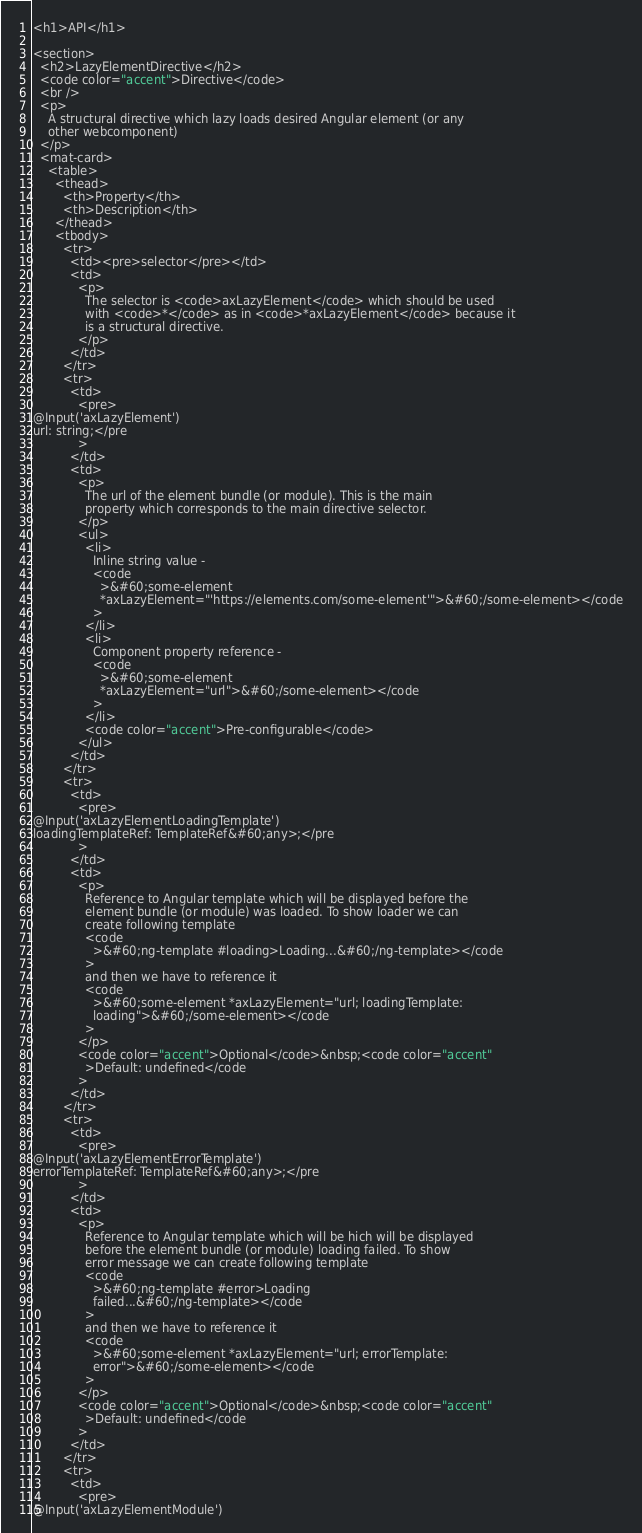<code> <loc_0><loc_0><loc_500><loc_500><_HTML_><h1>API</h1>

<section>
  <h2>LazyElementDirective</h2>
  <code color="accent">Directive</code>
  <br />
  <p>
    A structural directive which lazy loads desired Angular element (or any
    other webcomponent)
  </p>
  <mat-card>
    <table>
      <thead>
        <th>Property</th>
        <th>Description</th>
      </thead>
      <tbody>
        <tr>
          <td><pre>selector</pre></td>
          <td>
            <p>
              The selector is <code>axLazyElement</code> which should be used
              with <code>*</code> as in <code>*axLazyElement</code> because it
              is a structural directive.
            </p>
          </td>
        </tr>
        <tr>
          <td>
            <pre>
@Input('axLazyElement')
url: string;</pre
            >
          </td>
          <td>
            <p>
              The url of the element bundle (or module). This is the main
              property which corresponds to the main directive selector.
            </p>
            <ul>
              <li>
                Inline string value -
                <code
                  >&#60;some-element
                  *axLazyElement="'https://elements.com/some-element'">&#60;/some-element></code
                >
              </li>
              <li>
                Component property reference -
                <code
                  >&#60;some-element
                  *axLazyElement="url">&#60;/some-element></code
                >
              </li>
              <code color="accent">Pre-configurable</code>
            </ul>
          </td>
        </tr>
        <tr>
          <td>
            <pre>
@Input('axLazyElementLoadingTemplate')
loadingTemplateRef: TemplateRef&#60;any>;</pre
            >
          </td>
          <td>
            <p>
              Reference to Angular template which will be displayed before the
              element bundle (or module) was loaded. To show loader we can
              create following template
              <code
                >&#60;ng-template #loading>Loading...&#60;/ng-template></code
              >
              and then we have to reference it
              <code
                >&#60;some-element *axLazyElement="url; loadingTemplate:
                loading">&#60;/some-element></code
              >
            </p>
            <code color="accent">Optional</code>&nbsp;<code color="accent"
              >Default: undefined</code
            >
          </td>
        </tr>
        <tr>
          <td>
            <pre>
@Input('axLazyElementErrorTemplate')
errorTemplateRef: TemplateRef&#60;any>;</pre
            >
          </td>
          <td>
            <p>
              Reference to Angular template which will be hich will be displayed
              before the element bundle (or module) loading failed. To show
              error message we can create following template
              <code
                >&#60;ng-template #error>Loading
                failed...&#60;/ng-template></code
              >
              and then we have to reference it
              <code
                >&#60;some-element *axLazyElement="url; errorTemplate:
                error">&#60;/some-element></code
              >
            </p>
            <code color="accent">Optional</code>&nbsp;<code color="accent"
              >Default: undefined</code
            >
          </td>
        </tr>
        <tr>
          <td>
            <pre>
@Input('axLazyElementModule')</code> 